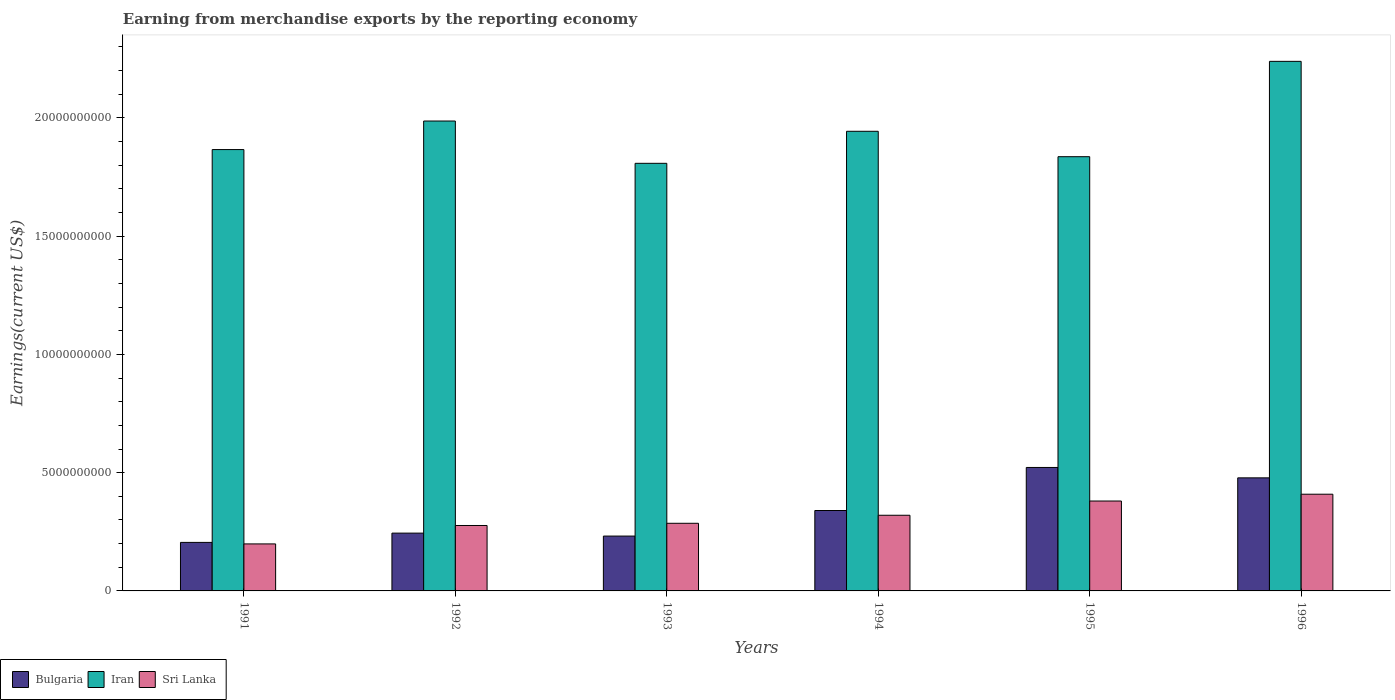How many different coloured bars are there?
Offer a very short reply. 3. Are the number of bars per tick equal to the number of legend labels?
Offer a very short reply. Yes. How many bars are there on the 4th tick from the right?
Give a very brief answer. 3. What is the label of the 6th group of bars from the left?
Your response must be concise. 1996. What is the amount earned from merchandise exports in Bulgaria in 1992?
Offer a terse response. 2.44e+09. Across all years, what is the maximum amount earned from merchandise exports in Iran?
Your answer should be compact. 2.24e+1. Across all years, what is the minimum amount earned from merchandise exports in Sri Lanka?
Make the answer very short. 1.99e+09. What is the total amount earned from merchandise exports in Bulgaria in the graph?
Your answer should be compact. 2.02e+1. What is the difference between the amount earned from merchandise exports in Bulgaria in 1994 and that in 1995?
Provide a short and direct response. -1.82e+09. What is the difference between the amount earned from merchandise exports in Bulgaria in 1994 and the amount earned from merchandise exports in Sri Lanka in 1995?
Provide a short and direct response. -4.01e+08. What is the average amount earned from merchandise exports in Iran per year?
Provide a succinct answer. 1.95e+1. In the year 1996, what is the difference between the amount earned from merchandise exports in Bulgaria and amount earned from merchandise exports in Iran?
Make the answer very short. -1.76e+1. In how many years, is the amount earned from merchandise exports in Iran greater than 11000000000 US$?
Make the answer very short. 6. What is the ratio of the amount earned from merchandise exports in Sri Lanka in 1992 to that in 1994?
Provide a succinct answer. 0.86. Is the amount earned from merchandise exports in Iran in 1994 less than that in 1995?
Your answer should be very brief. No. Is the difference between the amount earned from merchandise exports in Bulgaria in 1994 and 1995 greater than the difference between the amount earned from merchandise exports in Iran in 1994 and 1995?
Your answer should be very brief. No. What is the difference between the highest and the second highest amount earned from merchandise exports in Iran?
Provide a succinct answer. 2.52e+09. What is the difference between the highest and the lowest amount earned from merchandise exports in Iran?
Keep it short and to the point. 4.31e+09. In how many years, is the amount earned from merchandise exports in Sri Lanka greater than the average amount earned from merchandise exports in Sri Lanka taken over all years?
Give a very brief answer. 3. Is the sum of the amount earned from merchandise exports in Iran in 1992 and 1994 greater than the maximum amount earned from merchandise exports in Sri Lanka across all years?
Provide a succinct answer. Yes. What does the 3rd bar from the left in 1996 represents?
Ensure brevity in your answer.  Sri Lanka. What does the 1st bar from the right in 1996 represents?
Your response must be concise. Sri Lanka. Are the values on the major ticks of Y-axis written in scientific E-notation?
Ensure brevity in your answer.  No. Does the graph contain grids?
Keep it short and to the point. No. What is the title of the graph?
Your answer should be very brief. Earning from merchandise exports by the reporting economy. What is the label or title of the X-axis?
Your response must be concise. Years. What is the label or title of the Y-axis?
Ensure brevity in your answer.  Earnings(current US$). What is the Earnings(current US$) of Bulgaria in 1991?
Provide a short and direct response. 2.05e+09. What is the Earnings(current US$) in Iran in 1991?
Offer a terse response. 1.87e+1. What is the Earnings(current US$) of Sri Lanka in 1991?
Make the answer very short. 1.99e+09. What is the Earnings(current US$) in Bulgaria in 1992?
Keep it short and to the point. 2.44e+09. What is the Earnings(current US$) in Iran in 1992?
Your answer should be compact. 1.99e+1. What is the Earnings(current US$) in Sri Lanka in 1992?
Your answer should be very brief. 2.77e+09. What is the Earnings(current US$) in Bulgaria in 1993?
Your answer should be very brief. 2.32e+09. What is the Earnings(current US$) of Iran in 1993?
Keep it short and to the point. 1.81e+1. What is the Earnings(current US$) in Sri Lanka in 1993?
Make the answer very short. 2.86e+09. What is the Earnings(current US$) of Bulgaria in 1994?
Keep it short and to the point. 3.40e+09. What is the Earnings(current US$) of Iran in 1994?
Ensure brevity in your answer.  1.94e+1. What is the Earnings(current US$) in Sri Lanka in 1994?
Offer a very short reply. 3.20e+09. What is the Earnings(current US$) of Bulgaria in 1995?
Give a very brief answer. 5.22e+09. What is the Earnings(current US$) of Iran in 1995?
Give a very brief answer. 1.84e+1. What is the Earnings(current US$) in Sri Lanka in 1995?
Your answer should be very brief. 3.80e+09. What is the Earnings(current US$) of Bulgaria in 1996?
Make the answer very short. 4.78e+09. What is the Earnings(current US$) of Iran in 1996?
Provide a short and direct response. 2.24e+1. What is the Earnings(current US$) in Sri Lanka in 1996?
Keep it short and to the point. 4.09e+09. Across all years, what is the maximum Earnings(current US$) in Bulgaria?
Provide a short and direct response. 5.22e+09. Across all years, what is the maximum Earnings(current US$) in Iran?
Keep it short and to the point. 2.24e+1. Across all years, what is the maximum Earnings(current US$) in Sri Lanka?
Provide a short and direct response. 4.09e+09. Across all years, what is the minimum Earnings(current US$) in Bulgaria?
Ensure brevity in your answer.  2.05e+09. Across all years, what is the minimum Earnings(current US$) of Iran?
Your answer should be compact. 1.81e+1. Across all years, what is the minimum Earnings(current US$) of Sri Lanka?
Give a very brief answer. 1.99e+09. What is the total Earnings(current US$) in Bulgaria in the graph?
Your response must be concise. 2.02e+1. What is the total Earnings(current US$) of Iran in the graph?
Offer a very short reply. 1.17e+11. What is the total Earnings(current US$) of Sri Lanka in the graph?
Your response must be concise. 1.87e+1. What is the difference between the Earnings(current US$) of Bulgaria in 1991 and that in 1992?
Offer a terse response. -3.92e+08. What is the difference between the Earnings(current US$) of Iran in 1991 and that in 1992?
Your answer should be very brief. -1.21e+09. What is the difference between the Earnings(current US$) of Sri Lanka in 1991 and that in 1992?
Offer a terse response. -7.79e+08. What is the difference between the Earnings(current US$) in Bulgaria in 1991 and that in 1993?
Give a very brief answer. -2.68e+08. What is the difference between the Earnings(current US$) in Iran in 1991 and that in 1993?
Ensure brevity in your answer.  5.81e+08. What is the difference between the Earnings(current US$) of Sri Lanka in 1991 and that in 1993?
Your answer should be compact. -8.72e+08. What is the difference between the Earnings(current US$) of Bulgaria in 1991 and that in 1994?
Keep it short and to the point. -1.35e+09. What is the difference between the Earnings(current US$) of Iran in 1991 and that in 1994?
Provide a short and direct response. -7.73e+08. What is the difference between the Earnings(current US$) in Sri Lanka in 1991 and that in 1994?
Your response must be concise. -1.21e+09. What is the difference between the Earnings(current US$) in Bulgaria in 1991 and that in 1995?
Your answer should be compact. -3.17e+09. What is the difference between the Earnings(current US$) in Iran in 1991 and that in 1995?
Offer a very short reply. 3.01e+08. What is the difference between the Earnings(current US$) in Sri Lanka in 1991 and that in 1995?
Give a very brief answer. -1.81e+09. What is the difference between the Earnings(current US$) in Bulgaria in 1991 and that in 1996?
Give a very brief answer. -2.73e+09. What is the difference between the Earnings(current US$) of Iran in 1991 and that in 1996?
Provide a succinct answer. -3.73e+09. What is the difference between the Earnings(current US$) of Sri Lanka in 1991 and that in 1996?
Offer a very short reply. -2.10e+09. What is the difference between the Earnings(current US$) of Bulgaria in 1992 and that in 1993?
Provide a short and direct response. 1.24e+08. What is the difference between the Earnings(current US$) of Iran in 1992 and that in 1993?
Keep it short and to the point. 1.79e+09. What is the difference between the Earnings(current US$) of Sri Lanka in 1992 and that in 1993?
Offer a very short reply. -9.29e+07. What is the difference between the Earnings(current US$) of Bulgaria in 1992 and that in 1994?
Give a very brief answer. -9.56e+08. What is the difference between the Earnings(current US$) in Iran in 1992 and that in 1994?
Give a very brief answer. 4.34e+08. What is the difference between the Earnings(current US$) in Sri Lanka in 1992 and that in 1994?
Keep it short and to the point. -4.32e+08. What is the difference between the Earnings(current US$) in Bulgaria in 1992 and that in 1995?
Your response must be concise. -2.78e+09. What is the difference between the Earnings(current US$) in Iran in 1992 and that in 1995?
Keep it short and to the point. 1.51e+09. What is the difference between the Earnings(current US$) in Sri Lanka in 1992 and that in 1995?
Ensure brevity in your answer.  -1.03e+09. What is the difference between the Earnings(current US$) of Bulgaria in 1992 and that in 1996?
Your answer should be very brief. -2.34e+09. What is the difference between the Earnings(current US$) in Iran in 1992 and that in 1996?
Offer a very short reply. -2.52e+09. What is the difference between the Earnings(current US$) in Sri Lanka in 1992 and that in 1996?
Offer a terse response. -1.32e+09. What is the difference between the Earnings(current US$) in Bulgaria in 1993 and that in 1994?
Ensure brevity in your answer.  -1.08e+09. What is the difference between the Earnings(current US$) of Iran in 1993 and that in 1994?
Your answer should be compact. -1.35e+09. What is the difference between the Earnings(current US$) of Sri Lanka in 1993 and that in 1994?
Ensure brevity in your answer.  -3.40e+08. What is the difference between the Earnings(current US$) in Bulgaria in 1993 and that in 1995?
Keep it short and to the point. -2.90e+09. What is the difference between the Earnings(current US$) of Iran in 1993 and that in 1995?
Keep it short and to the point. -2.80e+08. What is the difference between the Earnings(current US$) of Sri Lanka in 1993 and that in 1995?
Provide a succinct answer. -9.42e+08. What is the difference between the Earnings(current US$) of Bulgaria in 1993 and that in 1996?
Your response must be concise. -2.46e+09. What is the difference between the Earnings(current US$) in Iran in 1993 and that in 1996?
Keep it short and to the point. -4.31e+09. What is the difference between the Earnings(current US$) of Sri Lanka in 1993 and that in 1996?
Your response must be concise. -1.23e+09. What is the difference between the Earnings(current US$) of Bulgaria in 1994 and that in 1995?
Provide a short and direct response. -1.82e+09. What is the difference between the Earnings(current US$) of Iran in 1994 and that in 1995?
Your response must be concise. 1.07e+09. What is the difference between the Earnings(current US$) of Sri Lanka in 1994 and that in 1995?
Ensure brevity in your answer.  -6.02e+08. What is the difference between the Earnings(current US$) of Bulgaria in 1994 and that in 1996?
Your answer should be very brief. -1.38e+09. What is the difference between the Earnings(current US$) of Iran in 1994 and that in 1996?
Offer a very short reply. -2.96e+09. What is the difference between the Earnings(current US$) in Sri Lanka in 1994 and that in 1996?
Provide a short and direct response. -8.90e+08. What is the difference between the Earnings(current US$) of Bulgaria in 1995 and that in 1996?
Your answer should be compact. 4.40e+08. What is the difference between the Earnings(current US$) of Iran in 1995 and that in 1996?
Offer a terse response. -4.03e+09. What is the difference between the Earnings(current US$) in Sri Lanka in 1995 and that in 1996?
Your response must be concise. -2.88e+08. What is the difference between the Earnings(current US$) of Bulgaria in 1991 and the Earnings(current US$) of Iran in 1992?
Keep it short and to the point. -1.78e+1. What is the difference between the Earnings(current US$) of Bulgaria in 1991 and the Earnings(current US$) of Sri Lanka in 1992?
Offer a very short reply. -7.15e+08. What is the difference between the Earnings(current US$) in Iran in 1991 and the Earnings(current US$) in Sri Lanka in 1992?
Keep it short and to the point. 1.59e+1. What is the difference between the Earnings(current US$) of Bulgaria in 1991 and the Earnings(current US$) of Iran in 1993?
Make the answer very short. -1.60e+1. What is the difference between the Earnings(current US$) in Bulgaria in 1991 and the Earnings(current US$) in Sri Lanka in 1993?
Your answer should be very brief. -8.08e+08. What is the difference between the Earnings(current US$) in Iran in 1991 and the Earnings(current US$) in Sri Lanka in 1993?
Keep it short and to the point. 1.58e+1. What is the difference between the Earnings(current US$) in Bulgaria in 1991 and the Earnings(current US$) in Iran in 1994?
Your response must be concise. -1.74e+1. What is the difference between the Earnings(current US$) in Bulgaria in 1991 and the Earnings(current US$) in Sri Lanka in 1994?
Make the answer very short. -1.15e+09. What is the difference between the Earnings(current US$) in Iran in 1991 and the Earnings(current US$) in Sri Lanka in 1994?
Your answer should be compact. 1.55e+1. What is the difference between the Earnings(current US$) in Bulgaria in 1991 and the Earnings(current US$) in Iran in 1995?
Offer a very short reply. -1.63e+1. What is the difference between the Earnings(current US$) of Bulgaria in 1991 and the Earnings(current US$) of Sri Lanka in 1995?
Give a very brief answer. -1.75e+09. What is the difference between the Earnings(current US$) in Iran in 1991 and the Earnings(current US$) in Sri Lanka in 1995?
Provide a succinct answer. 1.49e+1. What is the difference between the Earnings(current US$) in Bulgaria in 1991 and the Earnings(current US$) in Iran in 1996?
Offer a terse response. -2.03e+1. What is the difference between the Earnings(current US$) in Bulgaria in 1991 and the Earnings(current US$) in Sri Lanka in 1996?
Make the answer very short. -2.04e+09. What is the difference between the Earnings(current US$) of Iran in 1991 and the Earnings(current US$) of Sri Lanka in 1996?
Make the answer very short. 1.46e+1. What is the difference between the Earnings(current US$) in Bulgaria in 1992 and the Earnings(current US$) in Iran in 1993?
Your answer should be compact. -1.56e+1. What is the difference between the Earnings(current US$) in Bulgaria in 1992 and the Earnings(current US$) in Sri Lanka in 1993?
Make the answer very short. -4.16e+08. What is the difference between the Earnings(current US$) in Iran in 1992 and the Earnings(current US$) in Sri Lanka in 1993?
Your response must be concise. 1.70e+1. What is the difference between the Earnings(current US$) in Bulgaria in 1992 and the Earnings(current US$) in Iran in 1994?
Offer a terse response. -1.70e+1. What is the difference between the Earnings(current US$) of Bulgaria in 1992 and the Earnings(current US$) of Sri Lanka in 1994?
Your answer should be compact. -7.55e+08. What is the difference between the Earnings(current US$) of Iran in 1992 and the Earnings(current US$) of Sri Lanka in 1994?
Your response must be concise. 1.67e+1. What is the difference between the Earnings(current US$) in Bulgaria in 1992 and the Earnings(current US$) in Iran in 1995?
Offer a very short reply. -1.59e+1. What is the difference between the Earnings(current US$) in Bulgaria in 1992 and the Earnings(current US$) in Sri Lanka in 1995?
Your answer should be compact. -1.36e+09. What is the difference between the Earnings(current US$) of Iran in 1992 and the Earnings(current US$) of Sri Lanka in 1995?
Provide a short and direct response. 1.61e+1. What is the difference between the Earnings(current US$) of Bulgaria in 1992 and the Earnings(current US$) of Iran in 1996?
Provide a short and direct response. -1.99e+1. What is the difference between the Earnings(current US$) of Bulgaria in 1992 and the Earnings(current US$) of Sri Lanka in 1996?
Make the answer very short. -1.65e+09. What is the difference between the Earnings(current US$) in Iran in 1992 and the Earnings(current US$) in Sri Lanka in 1996?
Offer a terse response. 1.58e+1. What is the difference between the Earnings(current US$) of Bulgaria in 1993 and the Earnings(current US$) of Iran in 1994?
Make the answer very short. -1.71e+1. What is the difference between the Earnings(current US$) in Bulgaria in 1993 and the Earnings(current US$) in Sri Lanka in 1994?
Offer a very short reply. -8.80e+08. What is the difference between the Earnings(current US$) of Iran in 1993 and the Earnings(current US$) of Sri Lanka in 1994?
Keep it short and to the point. 1.49e+1. What is the difference between the Earnings(current US$) of Bulgaria in 1993 and the Earnings(current US$) of Iran in 1995?
Your answer should be compact. -1.60e+1. What is the difference between the Earnings(current US$) of Bulgaria in 1993 and the Earnings(current US$) of Sri Lanka in 1995?
Your answer should be compact. -1.48e+09. What is the difference between the Earnings(current US$) in Iran in 1993 and the Earnings(current US$) in Sri Lanka in 1995?
Keep it short and to the point. 1.43e+1. What is the difference between the Earnings(current US$) of Bulgaria in 1993 and the Earnings(current US$) of Iran in 1996?
Your response must be concise. -2.01e+1. What is the difference between the Earnings(current US$) of Bulgaria in 1993 and the Earnings(current US$) of Sri Lanka in 1996?
Your answer should be very brief. -1.77e+09. What is the difference between the Earnings(current US$) in Iran in 1993 and the Earnings(current US$) in Sri Lanka in 1996?
Ensure brevity in your answer.  1.40e+1. What is the difference between the Earnings(current US$) in Bulgaria in 1994 and the Earnings(current US$) in Iran in 1995?
Offer a very short reply. -1.50e+1. What is the difference between the Earnings(current US$) of Bulgaria in 1994 and the Earnings(current US$) of Sri Lanka in 1995?
Your answer should be compact. -4.01e+08. What is the difference between the Earnings(current US$) of Iran in 1994 and the Earnings(current US$) of Sri Lanka in 1995?
Give a very brief answer. 1.56e+1. What is the difference between the Earnings(current US$) in Bulgaria in 1994 and the Earnings(current US$) in Iran in 1996?
Provide a short and direct response. -1.90e+1. What is the difference between the Earnings(current US$) of Bulgaria in 1994 and the Earnings(current US$) of Sri Lanka in 1996?
Offer a very short reply. -6.89e+08. What is the difference between the Earnings(current US$) in Iran in 1994 and the Earnings(current US$) in Sri Lanka in 1996?
Provide a short and direct response. 1.53e+1. What is the difference between the Earnings(current US$) in Bulgaria in 1995 and the Earnings(current US$) in Iran in 1996?
Offer a terse response. -1.72e+1. What is the difference between the Earnings(current US$) in Bulgaria in 1995 and the Earnings(current US$) in Sri Lanka in 1996?
Your answer should be compact. 1.13e+09. What is the difference between the Earnings(current US$) in Iran in 1995 and the Earnings(current US$) in Sri Lanka in 1996?
Keep it short and to the point. 1.43e+1. What is the average Earnings(current US$) in Bulgaria per year?
Provide a succinct answer. 3.37e+09. What is the average Earnings(current US$) of Iran per year?
Provide a short and direct response. 1.95e+1. What is the average Earnings(current US$) in Sri Lanka per year?
Keep it short and to the point. 3.12e+09. In the year 1991, what is the difference between the Earnings(current US$) of Bulgaria and Earnings(current US$) of Iran?
Your answer should be compact. -1.66e+1. In the year 1991, what is the difference between the Earnings(current US$) of Bulgaria and Earnings(current US$) of Sri Lanka?
Offer a terse response. 6.39e+07. In the year 1991, what is the difference between the Earnings(current US$) in Iran and Earnings(current US$) in Sri Lanka?
Your answer should be compact. 1.67e+1. In the year 1992, what is the difference between the Earnings(current US$) of Bulgaria and Earnings(current US$) of Iran?
Your response must be concise. -1.74e+1. In the year 1992, what is the difference between the Earnings(current US$) in Bulgaria and Earnings(current US$) in Sri Lanka?
Provide a short and direct response. -3.23e+08. In the year 1992, what is the difference between the Earnings(current US$) in Iran and Earnings(current US$) in Sri Lanka?
Your answer should be very brief. 1.71e+1. In the year 1993, what is the difference between the Earnings(current US$) in Bulgaria and Earnings(current US$) in Iran?
Keep it short and to the point. -1.58e+1. In the year 1993, what is the difference between the Earnings(current US$) of Bulgaria and Earnings(current US$) of Sri Lanka?
Your answer should be very brief. -5.40e+08. In the year 1993, what is the difference between the Earnings(current US$) in Iran and Earnings(current US$) in Sri Lanka?
Your response must be concise. 1.52e+1. In the year 1994, what is the difference between the Earnings(current US$) in Bulgaria and Earnings(current US$) in Iran?
Keep it short and to the point. -1.60e+1. In the year 1994, what is the difference between the Earnings(current US$) of Bulgaria and Earnings(current US$) of Sri Lanka?
Offer a terse response. 2.01e+08. In the year 1994, what is the difference between the Earnings(current US$) of Iran and Earnings(current US$) of Sri Lanka?
Make the answer very short. 1.62e+1. In the year 1995, what is the difference between the Earnings(current US$) of Bulgaria and Earnings(current US$) of Iran?
Your response must be concise. -1.31e+1. In the year 1995, what is the difference between the Earnings(current US$) in Bulgaria and Earnings(current US$) in Sri Lanka?
Offer a very short reply. 1.42e+09. In the year 1995, what is the difference between the Earnings(current US$) of Iran and Earnings(current US$) of Sri Lanka?
Give a very brief answer. 1.46e+1. In the year 1996, what is the difference between the Earnings(current US$) in Bulgaria and Earnings(current US$) in Iran?
Provide a short and direct response. -1.76e+1. In the year 1996, what is the difference between the Earnings(current US$) in Bulgaria and Earnings(current US$) in Sri Lanka?
Give a very brief answer. 6.92e+08. In the year 1996, what is the difference between the Earnings(current US$) of Iran and Earnings(current US$) of Sri Lanka?
Make the answer very short. 1.83e+1. What is the ratio of the Earnings(current US$) in Bulgaria in 1991 to that in 1992?
Make the answer very short. 0.84. What is the ratio of the Earnings(current US$) in Iran in 1991 to that in 1992?
Keep it short and to the point. 0.94. What is the ratio of the Earnings(current US$) in Sri Lanka in 1991 to that in 1992?
Your answer should be compact. 0.72. What is the ratio of the Earnings(current US$) in Bulgaria in 1991 to that in 1993?
Make the answer very short. 0.88. What is the ratio of the Earnings(current US$) in Iran in 1991 to that in 1993?
Ensure brevity in your answer.  1.03. What is the ratio of the Earnings(current US$) in Sri Lanka in 1991 to that in 1993?
Give a very brief answer. 0.7. What is the ratio of the Earnings(current US$) of Bulgaria in 1991 to that in 1994?
Your answer should be compact. 0.6. What is the ratio of the Earnings(current US$) of Iran in 1991 to that in 1994?
Give a very brief answer. 0.96. What is the ratio of the Earnings(current US$) in Sri Lanka in 1991 to that in 1994?
Provide a succinct answer. 0.62. What is the ratio of the Earnings(current US$) in Bulgaria in 1991 to that in 1995?
Provide a short and direct response. 0.39. What is the ratio of the Earnings(current US$) of Iran in 1991 to that in 1995?
Ensure brevity in your answer.  1.02. What is the ratio of the Earnings(current US$) in Sri Lanka in 1991 to that in 1995?
Your answer should be compact. 0.52. What is the ratio of the Earnings(current US$) in Bulgaria in 1991 to that in 1996?
Ensure brevity in your answer.  0.43. What is the ratio of the Earnings(current US$) in Iran in 1991 to that in 1996?
Give a very brief answer. 0.83. What is the ratio of the Earnings(current US$) of Sri Lanka in 1991 to that in 1996?
Provide a short and direct response. 0.49. What is the ratio of the Earnings(current US$) in Bulgaria in 1992 to that in 1993?
Offer a terse response. 1.05. What is the ratio of the Earnings(current US$) of Iran in 1992 to that in 1993?
Your answer should be compact. 1.1. What is the ratio of the Earnings(current US$) of Sri Lanka in 1992 to that in 1993?
Offer a terse response. 0.97. What is the ratio of the Earnings(current US$) of Bulgaria in 1992 to that in 1994?
Give a very brief answer. 0.72. What is the ratio of the Earnings(current US$) of Iran in 1992 to that in 1994?
Ensure brevity in your answer.  1.02. What is the ratio of the Earnings(current US$) of Sri Lanka in 1992 to that in 1994?
Your response must be concise. 0.86. What is the ratio of the Earnings(current US$) in Bulgaria in 1992 to that in 1995?
Your answer should be compact. 0.47. What is the ratio of the Earnings(current US$) of Iran in 1992 to that in 1995?
Ensure brevity in your answer.  1.08. What is the ratio of the Earnings(current US$) of Sri Lanka in 1992 to that in 1995?
Your response must be concise. 0.73. What is the ratio of the Earnings(current US$) of Bulgaria in 1992 to that in 1996?
Provide a succinct answer. 0.51. What is the ratio of the Earnings(current US$) of Iran in 1992 to that in 1996?
Give a very brief answer. 0.89. What is the ratio of the Earnings(current US$) in Sri Lanka in 1992 to that in 1996?
Your response must be concise. 0.68. What is the ratio of the Earnings(current US$) in Bulgaria in 1993 to that in 1994?
Your answer should be very brief. 0.68. What is the ratio of the Earnings(current US$) in Iran in 1993 to that in 1994?
Give a very brief answer. 0.93. What is the ratio of the Earnings(current US$) in Sri Lanka in 1993 to that in 1994?
Offer a terse response. 0.89. What is the ratio of the Earnings(current US$) of Bulgaria in 1993 to that in 1995?
Your response must be concise. 0.44. What is the ratio of the Earnings(current US$) of Iran in 1993 to that in 1995?
Keep it short and to the point. 0.98. What is the ratio of the Earnings(current US$) of Sri Lanka in 1993 to that in 1995?
Offer a very short reply. 0.75. What is the ratio of the Earnings(current US$) of Bulgaria in 1993 to that in 1996?
Offer a terse response. 0.49. What is the ratio of the Earnings(current US$) of Iran in 1993 to that in 1996?
Make the answer very short. 0.81. What is the ratio of the Earnings(current US$) of Sri Lanka in 1993 to that in 1996?
Make the answer very short. 0.7. What is the ratio of the Earnings(current US$) of Bulgaria in 1994 to that in 1995?
Provide a succinct answer. 0.65. What is the ratio of the Earnings(current US$) in Iran in 1994 to that in 1995?
Provide a short and direct response. 1.06. What is the ratio of the Earnings(current US$) in Sri Lanka in 1994 to that in 1995?
Keep it short and to the point. 0.84. What is the ratio of the Earnings(current US$) in Bulgaria in 1994 to that in 1996?
Keep it short and to the point. 0.71. What is the ratio of the Earnings(current US$) of Iran in 1994 to that in 1996?
Offer a terse response. 0.87. What is the ratio of the Earnings(current US$) of Sri Lanka in 1994 to that in 1996?
Provide a succinct answer. 0.78. What is the ratio of the Earnings(current US$) in Bulgaria in 1995 to that in 1996?
Your response must be concise. 1.09. What is the ratio of the Earnings(current US$) in Iran in 1995 to that in 1996?
Ensure brevity in your answer.  0.82. What is the ratio of the Earnings(current US$) in Sri Lanka in 1995 to that in 1996?
Keep it short and to the point. 0.93. What is the difference between the highest and the second highest Earnings(current US$) of Bulgaria?
Provide a succinct answer. 4.40e+08. What is the difference between the highest and the second highest Earnings(current US$) of Iran?
Provide a short and direct response. 2.52e+09. What is the difference between the highest and the second highest Earnings(current US$) of Sri Lanka?
Make the answer very short. 2.88e+08. What is the difference between the highest and the lowest Earnings(current US$) of Bulgaria?
Give a very brief answer. 3.17e+09. What is the difference between the highest and the lowest Earnings(current US$) of Iran?
Keep it short and to the point. 4.31e+09. What is the difference between the highest and the lowest Earnings(current US$) of Sri Lanka?
Offer a very short reply. 2.10e+09. 